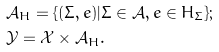<formula> <loc_0><loc_0><loc_500><loc_500>& \mathcal { A } _ { H } = \{ ( \Sigma , e ) | \Sigma \in \mathcal { A } , e \in H _ { \Sigma } \} ; \\ & \mathcal { Y } = \mathcal { X } \times \mathcal { A } _ { H } .</formula> 